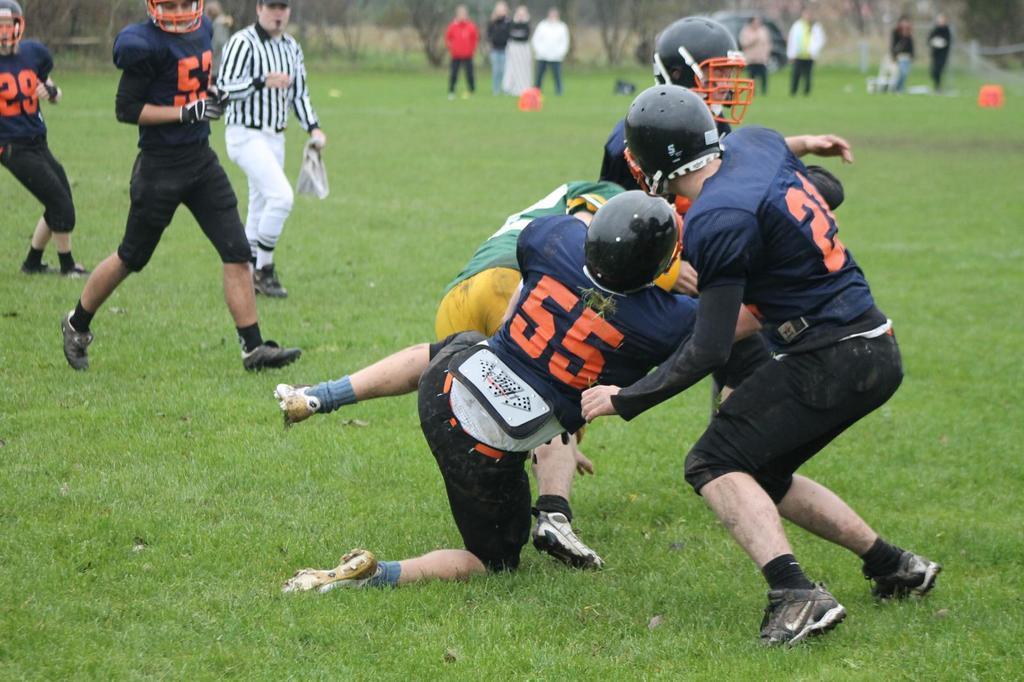Please provide a concise description of this image. In this image there are persons persons playing in the front. In the background there are persons standing and there are trees are there is a car in the front on the ground there is grass 